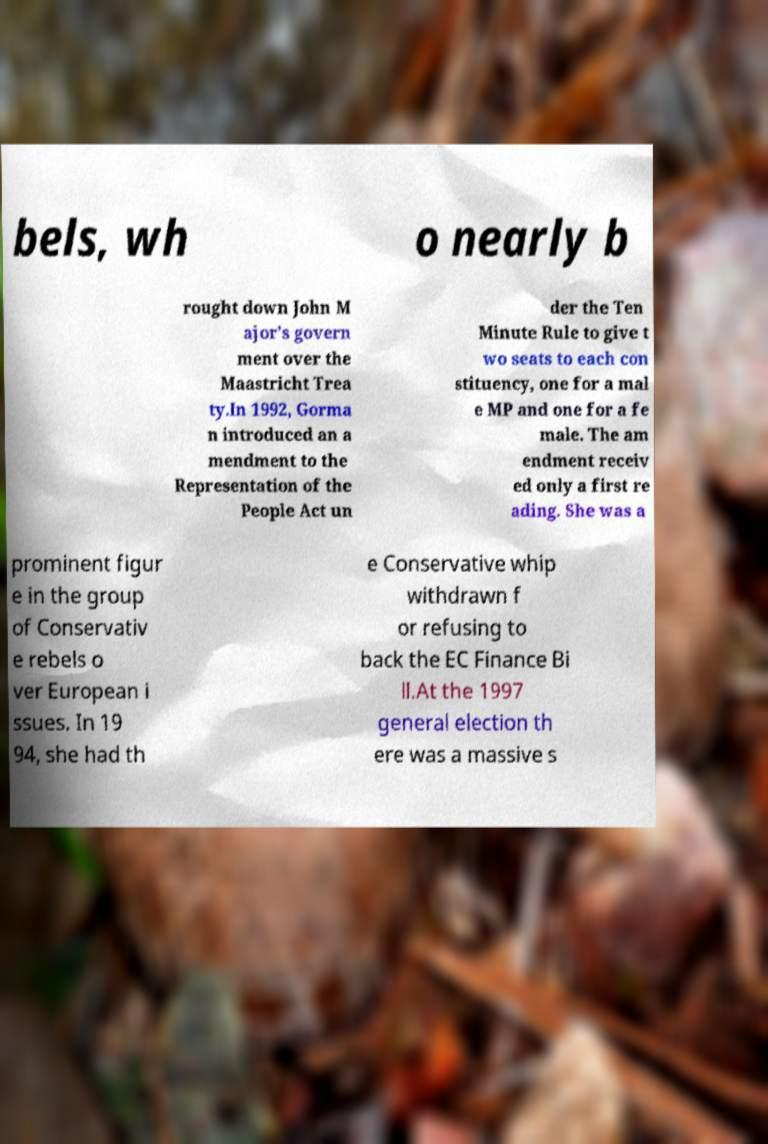Can you accurately transcribe the text from the provided image for me? bels, wh o nearly b rought down John M ajor's govern ment over the Maastricht Trea ty.In 1992, Gorma n introduced an a mendment to the Representation of the People Act un der the Ten Minute Rule to give t wo seats to each con stituency, one for a mal e MP and one for a fe male. The am endment receiv ed only a first re ading. She was a prominent figur e in the group of Conservativ e rebels o ver European i ssues. In 19 94, she had th e Conservative whip withdrawn f or refusing to back the EC Finance Bi ll.At the 1997 general election th ere was a massive s 